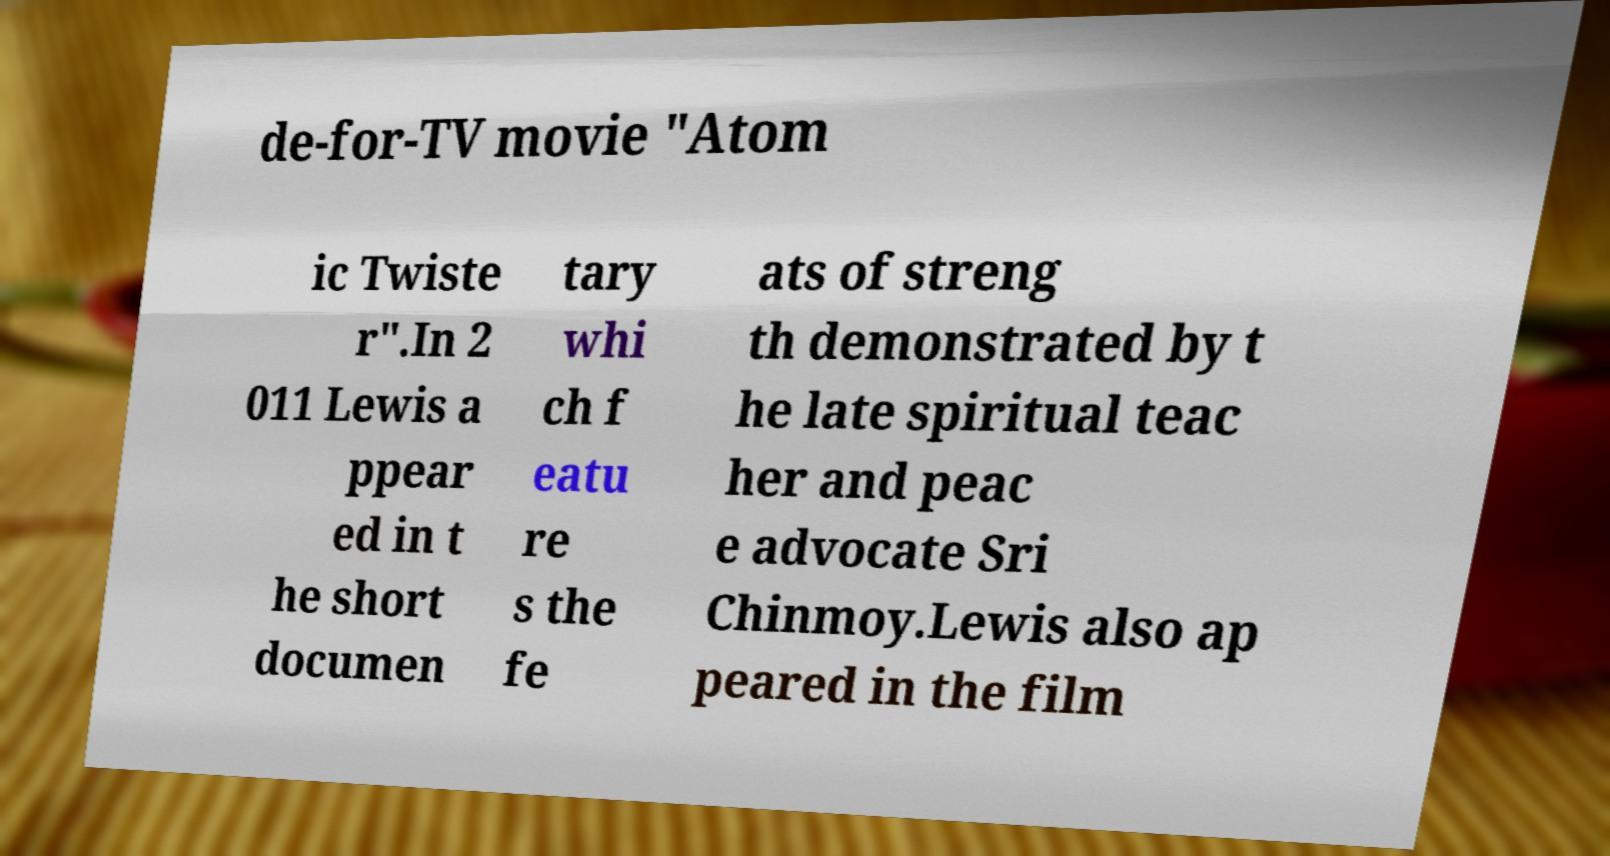Please read and relay the text visible in this image. What does it say? de-for-TV movie "Atom ic Twiste r".In 2 011 Lewis a ppear ed in t he short documen tary whi ch f eatu re s the fe ats of streng th demonstrated by t he late spiritual teac her and peac e advocate Sri Chinmoy.Lewis also ap peared in the film 